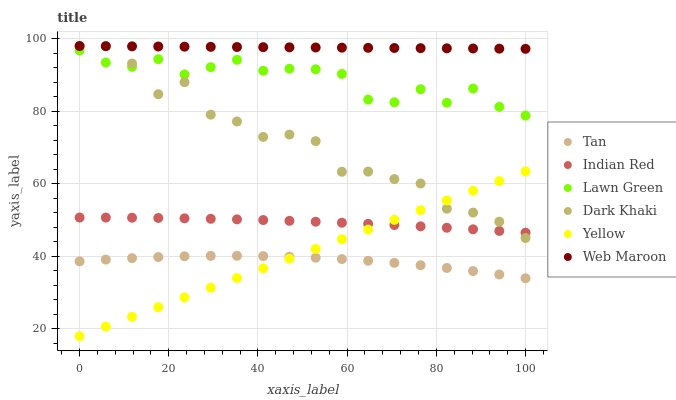Does Tan have the minimum area under the curve?
Answer yes or no. Yes. Does Web Maroon have the maximum area under the curve?
Answer yes or no. Yes. Does Yellow have the minimum area under the curve?
Answer yes or no. No. Does Yellow have the maximum area under the curve?
Answer yes or no. No. Is Yellow the smoothest?
Answer yes or no. Yes. Is Dark Khaki the roughest?
Answer yes or no. Yes. Is Web Maroon the smoothest?
Answer yes or no. No. Is Web Maroon the roughest?
Answer yes or no. No. Does Yellow have the lowest value?
Answer yes or no. Yes. Does Web Maroon have the lowest value?
Answer yes or no. No. Does Dark Khaki have the highest value?
Answer yes or no. Yes. Does Yellow have the highest value?
Answer yes or no. No. Is Tan less than Web Maroon?
Answer yes or no. Yes. Is Web Maroon greater than Indian Red?
Answer yes or no. Yes. Does Dark Khaki intersect Indian Red?
Answer yes or no. Yes. Is Dark Khaki less than Indian Red?
Answer yes or no. No. Is Dark Khaki greater than Indian Red?
Answer yes or no. No. Does Tan intersect Web Maroon?
Answer yes or no. No. 